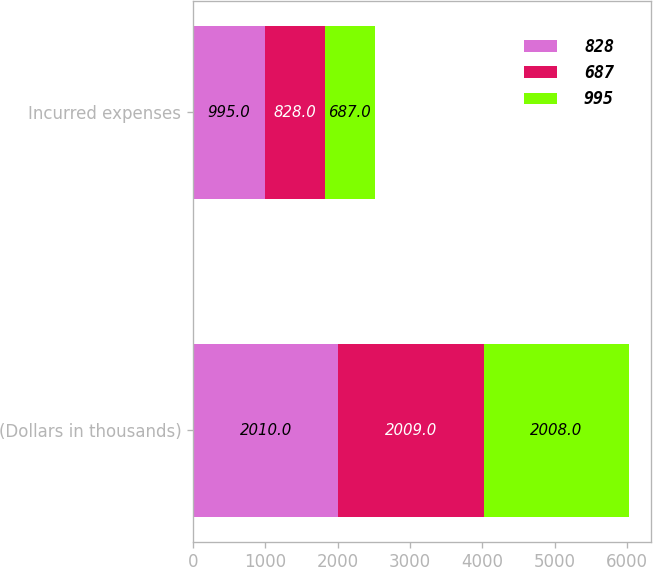Convert chart to OTSL. <chart><loc_0><loc_0><loc_500><loc_500><stacked_bar_chart><ecel><fcel>(Dollars in thousands)<fcel>Incurred expenses<nl><fcel>828<fcel>2010<fcel>995<nl><fcel>687<fcel>2009<fcel>828<nl><fcel>995<fcel>2008<fcel>687<nl></chart> 